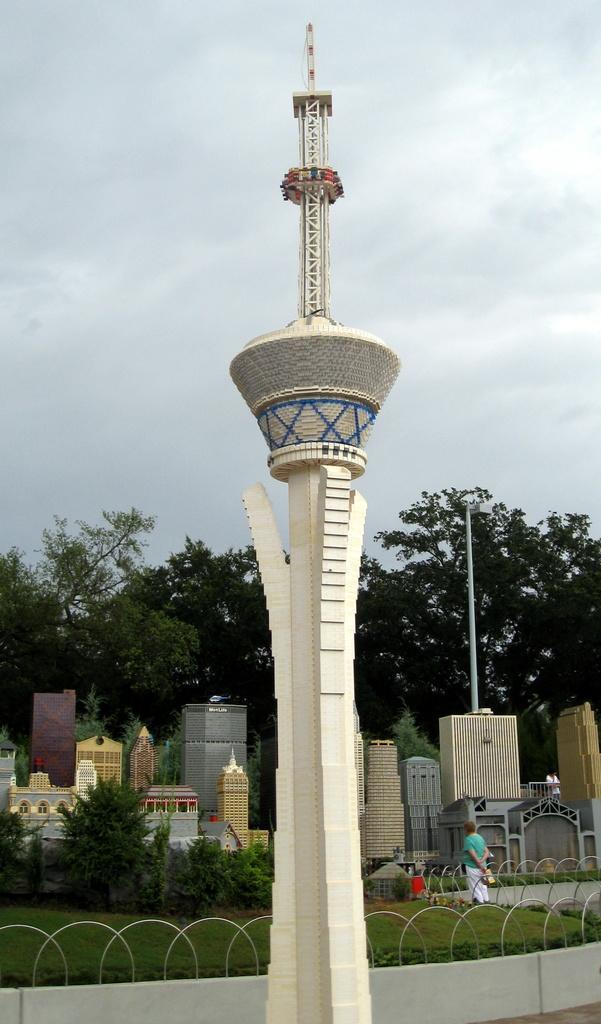Please provide a concise description of this image. This image consists of a tower. In the background, there are buildings along with trees. At the bottom, we can see green grass on the ground. At the top, there are clouds in the sky. 